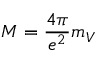Convert formula to latex. <formula><loc_0><loc_0><loc_500><loc_500>M = { \frac { 4 \pi } { e ^ { 2 } } } m _ { V }</formula> 